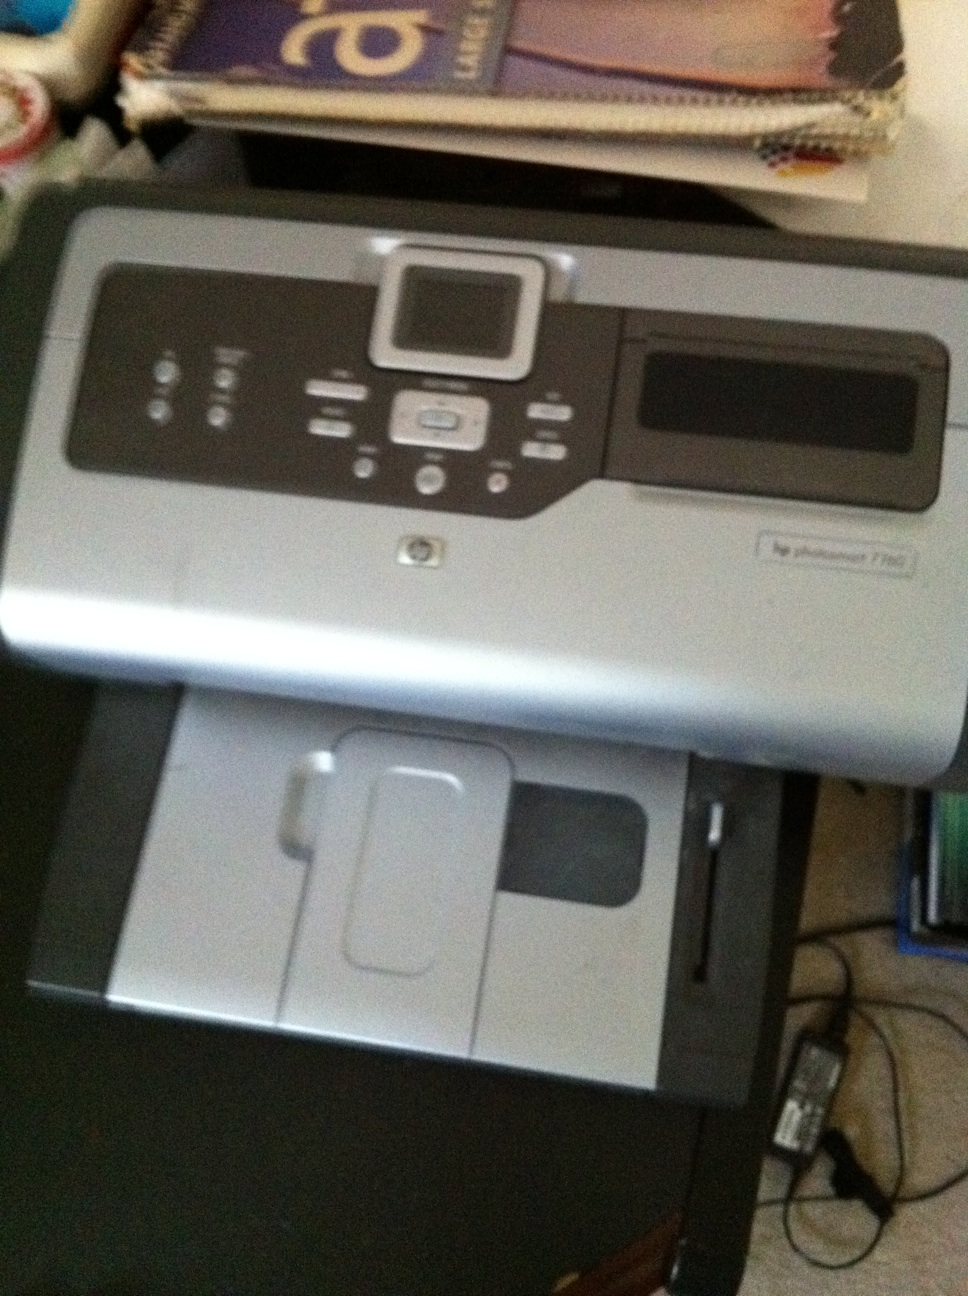Describe a scenario where this printer would be an ideal choice. This HP Photosmart 7280 printer would be an ideal choice for a home office setup where you need versatile printing options. It allows you to print high-quality documents and photos, offers scanning and copying features, and can connect to multiple devices via Ethernet or USB. Given its multi-functionality, it can handle various tasks efficiently, making it very suitable for small businesses or freelancers. 